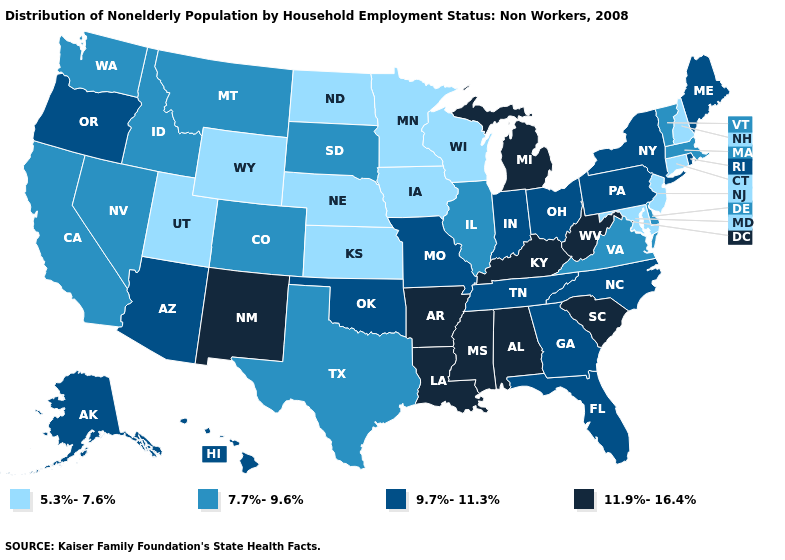Name the states that have a value in the range 9.7%-11.3%?
Quick response, please. Alaska, Arizona, Florida, Georgia, Hawaii, Indiana, Maine, Missouri, New York, North Carolina, Ohio, Oklahoma, Oregon, Pennsylvania, Rhode Island, Tennessee. Name the states that have a value in the range 11.9%-16.4%?
Be succinct. Alabama, Arkansas, Kentucky, Louisiana, Michigan, Mississippi, New Mexico, South Carolina, West Virginia. What is the value of Minnesota?
Give a very brief answer. 5.3%-7.6%. Among the states that border Nebraska , does Kansas have the highest value?
Short answer required. No. Does Hawaii have the highest value in the USA?
Be succinct. No. What is the highest value in states that border New Hampshire?
Quick response, please. 9.7%-11.3%. Does Arkansas have the highest value in the USA?
Give a very brief answer. Yes. Name the states that have a value in the range 5.3%-7.6%?
Be succinct. Connecticut, Iowa, Kansas, Maryland, Minnesota, Nebraska, New Hampshire, New Jersey, North Dakota, Utah, Wisconsin, Wyoming. Name the states that have a value in the range 7.7%-9.6%?
Concise answer only. California, Colorado, Delaware, Idaho, Illinois, Massachusetts, Montana, Nevada, South Dakota, Texas, Vermont, Virginia, Washington. What is the value of Maine?
Quick response, please. 9.7%-11.3%. Name the states that have a value in the range 9.7%-11.3%?
Be succinct. Alaska, Arizona, Florida, Georgia, Hawaii, Indiana, Maine, Missouri, New York, North Carolina, Ohio, Oklahoma, Oregon, Pennsylvania, Rhode Island, Tennessee. Which states have the lowest value in the West?
Quick response, please. Utah, Wyoming. What is the value of Colorado?
Concise answer only. 7.7%-9.6%. Among the states that border California , which have the highest value?
Concise answer only. Arizona, Oregon. How many symbols are there in the legend?
Short answer required. 4. 